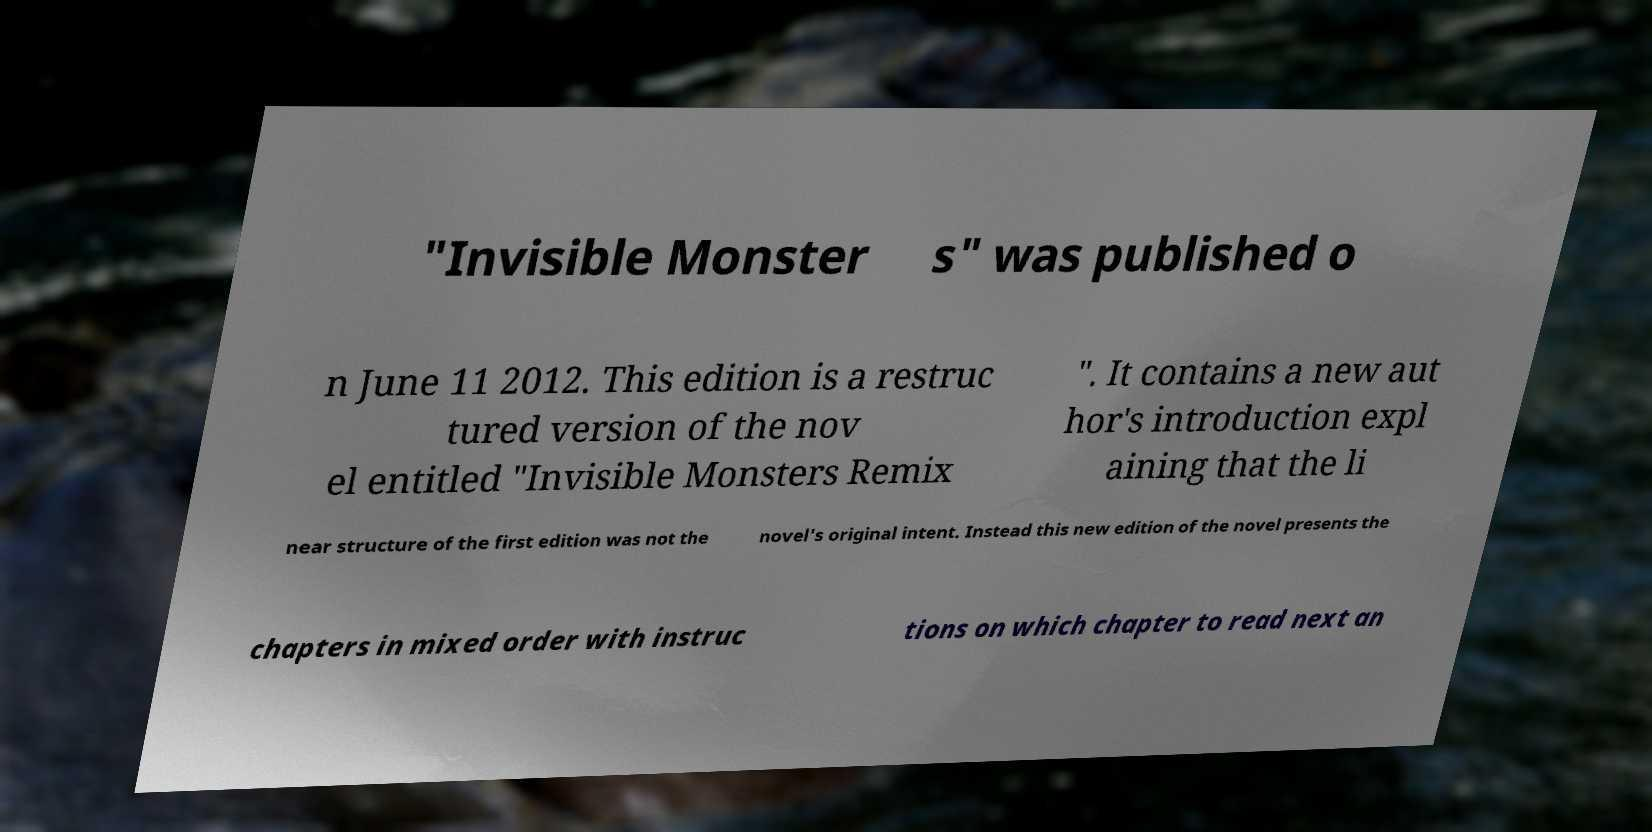What messages or text are displayed in this image? I need them in a readable, typed format. "Invisible Monster s" was published o n June 11 2012. This edition is a restruc tured version of the nov el entitled "Invisible Monsters Remix ". It contains a new aut hor's introduction expl aining that the li near structure of the first edition was not the novel's original intent. Instead this new edition of the novel presents the chapters in mixed order with instruc tions on which chapter to read next an 